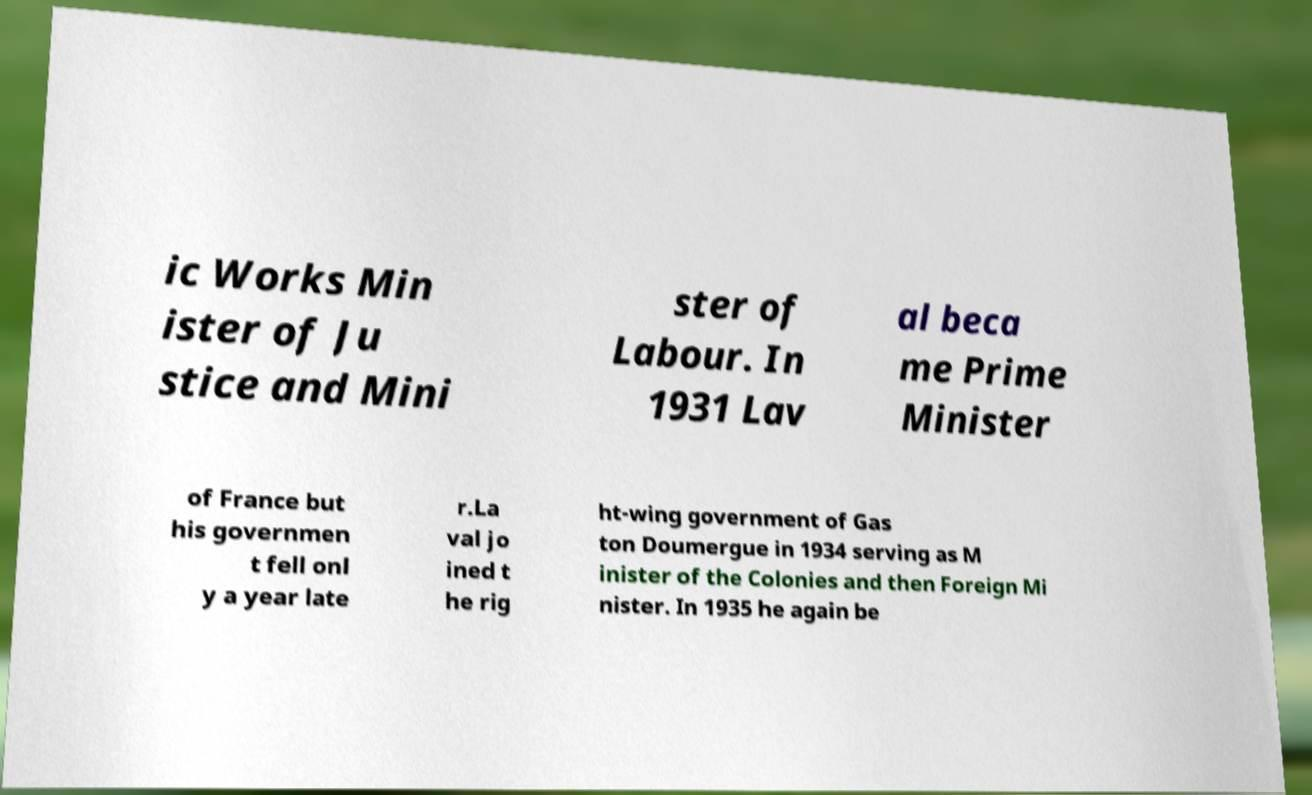There's text embedded in this image that I need extracted. Can you transcribe it verbatim? ic Works Min ister of Ju stice and Mini ster of Labour. In 1931 Lav al beca me Prime Minister of France but his governmen t fell onl y a year late r.La val jo ined t he rig ht-wing government of Gas ton Doumergue in 1934 serving as M inister of the Colonies and then Foreign Mi nister. In 1935 he again be 